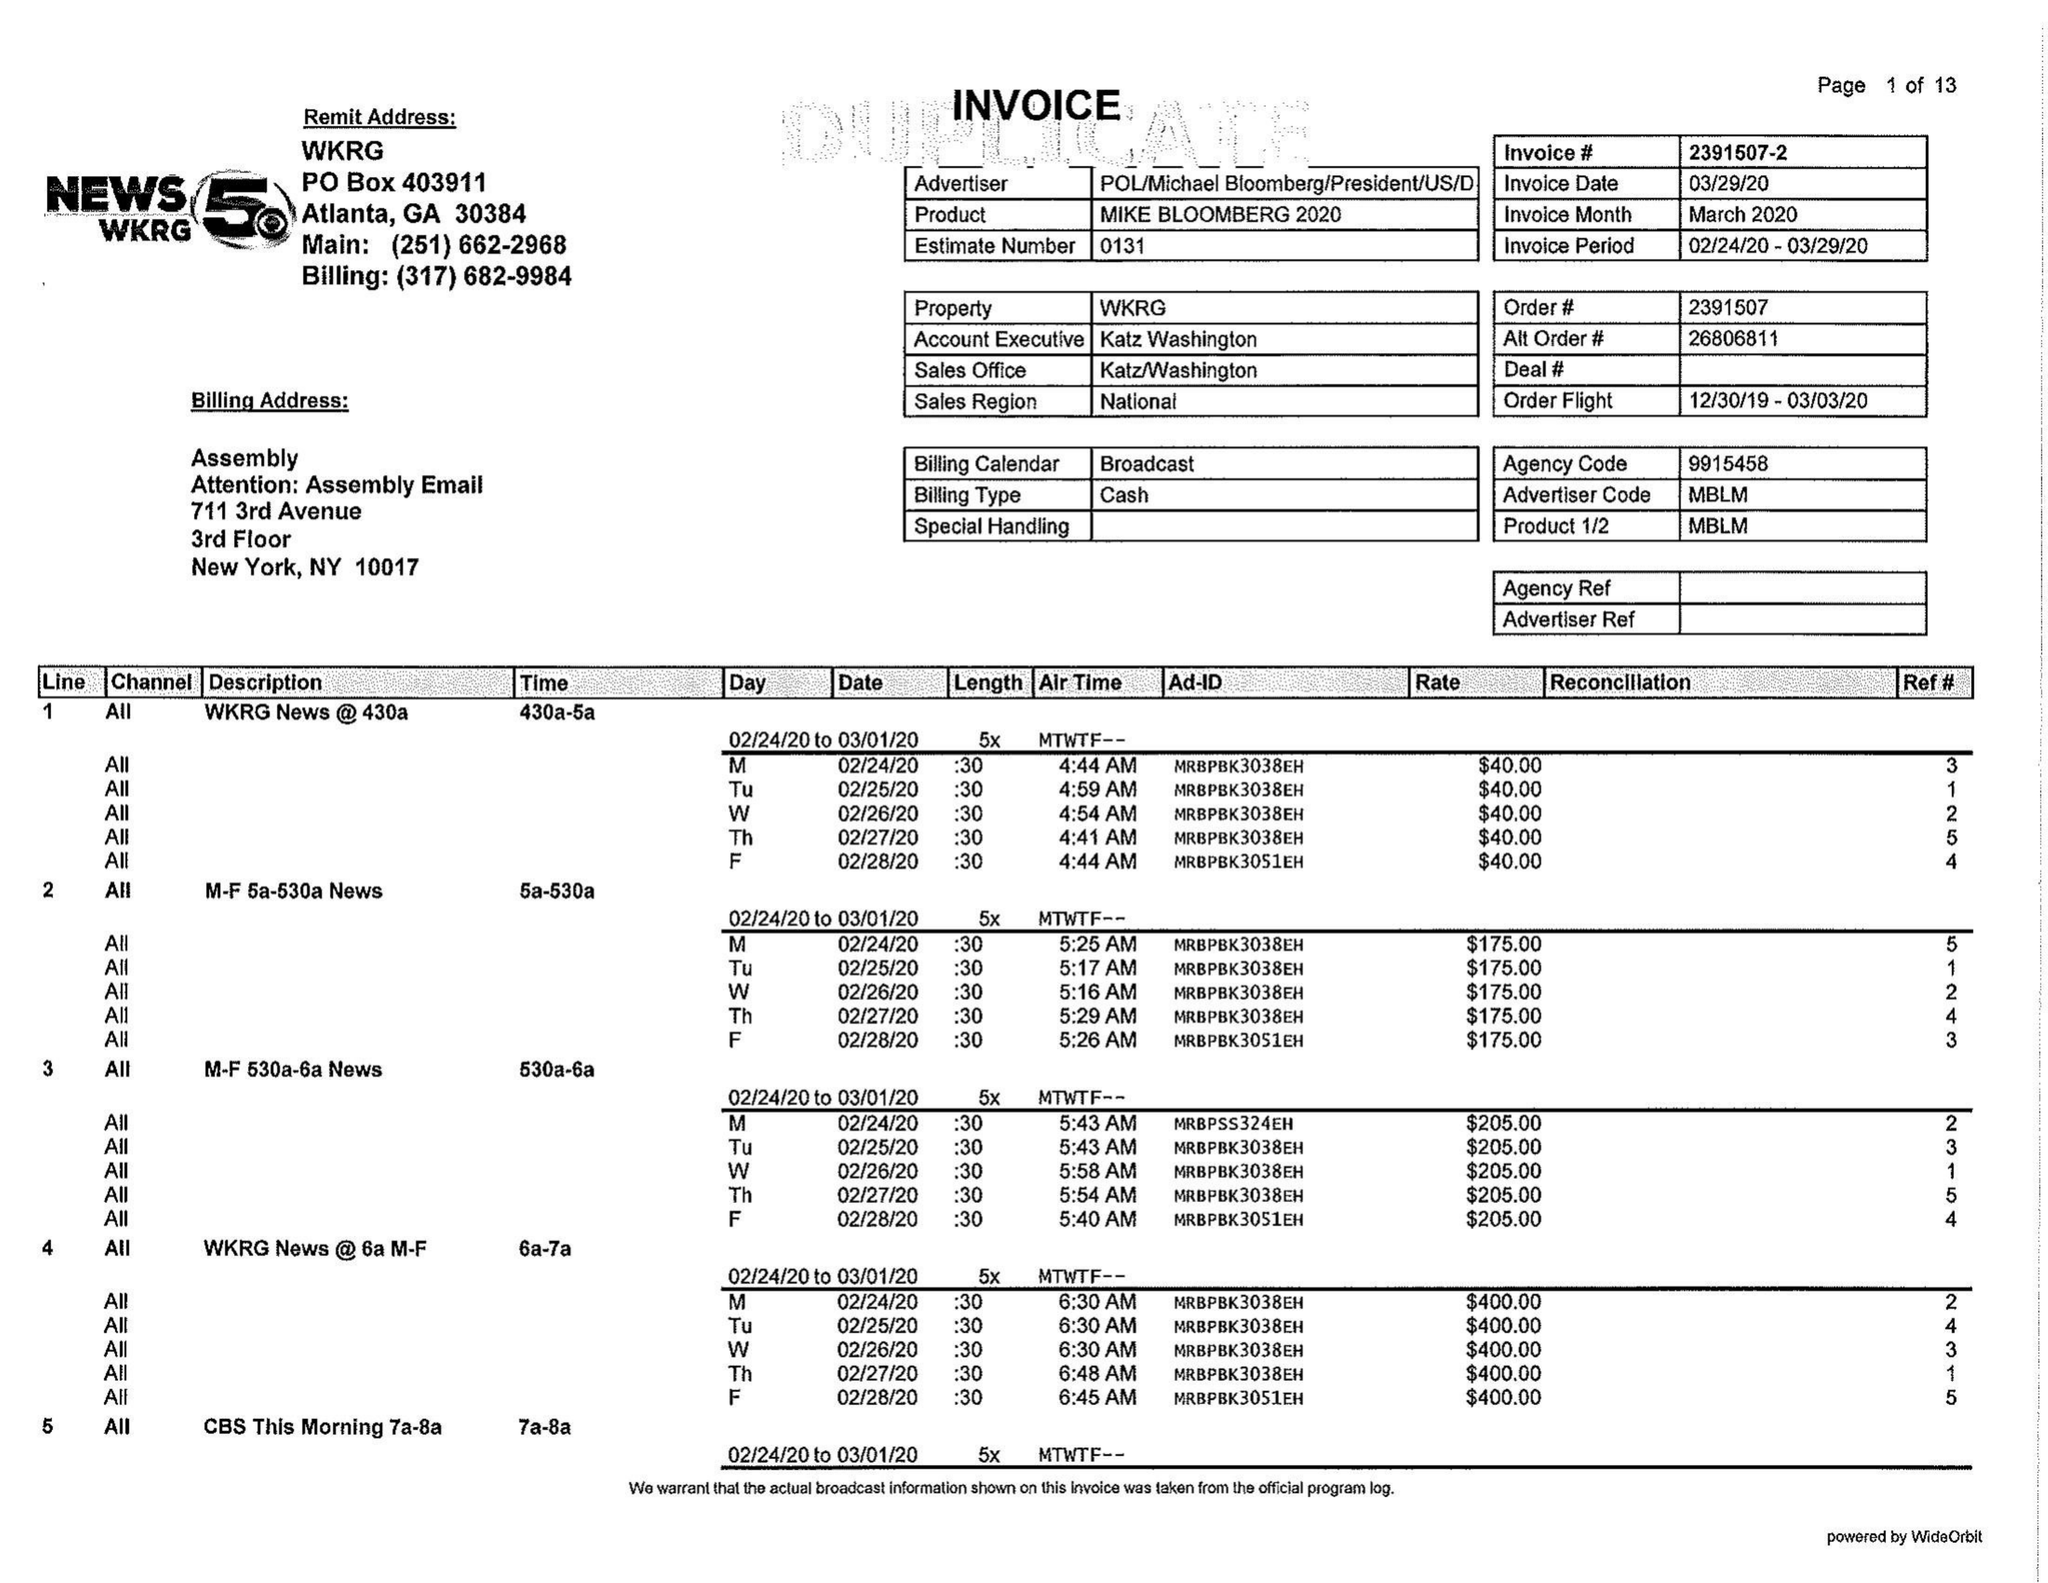What is the value for the gross_amount?
Answer the question using a single word or phrase. 133865.00 